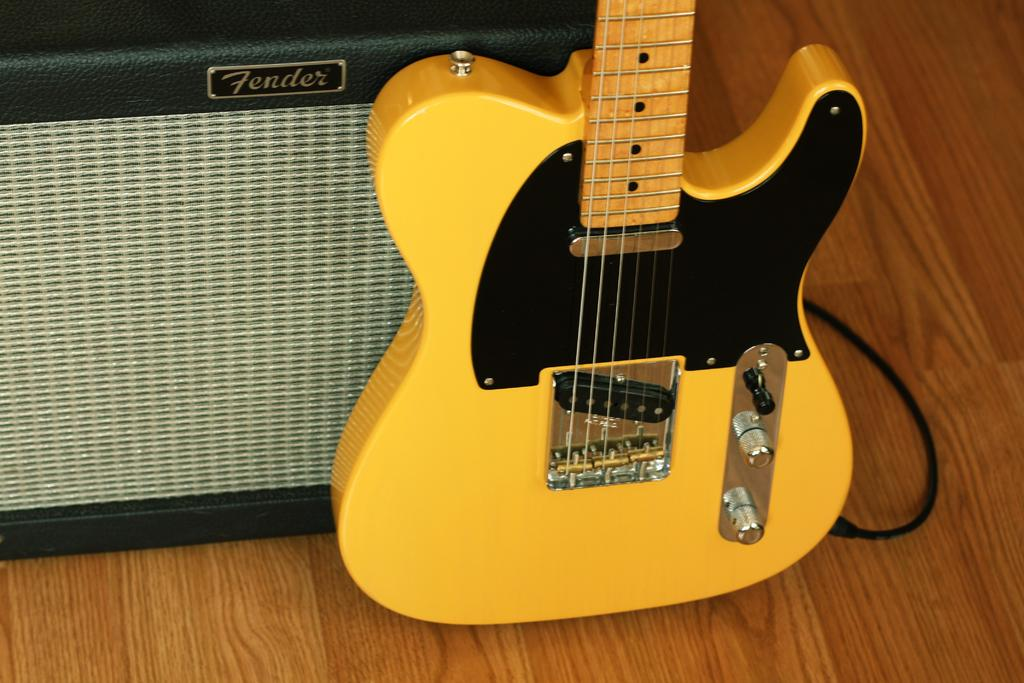What is the main object in the front of the image? There is a guitar in the front of the image. Is there anything connected to the guitar? Yes, there is a wire attached to the guitar. What can be seen in the background of the image? There is an object with text visible in the background of the image. How many springs are attached to the guitar in the image? There are no springs attached to the guitar in the image. What word is written on the guitar in the image? There is no word written on the guitar in the image. 